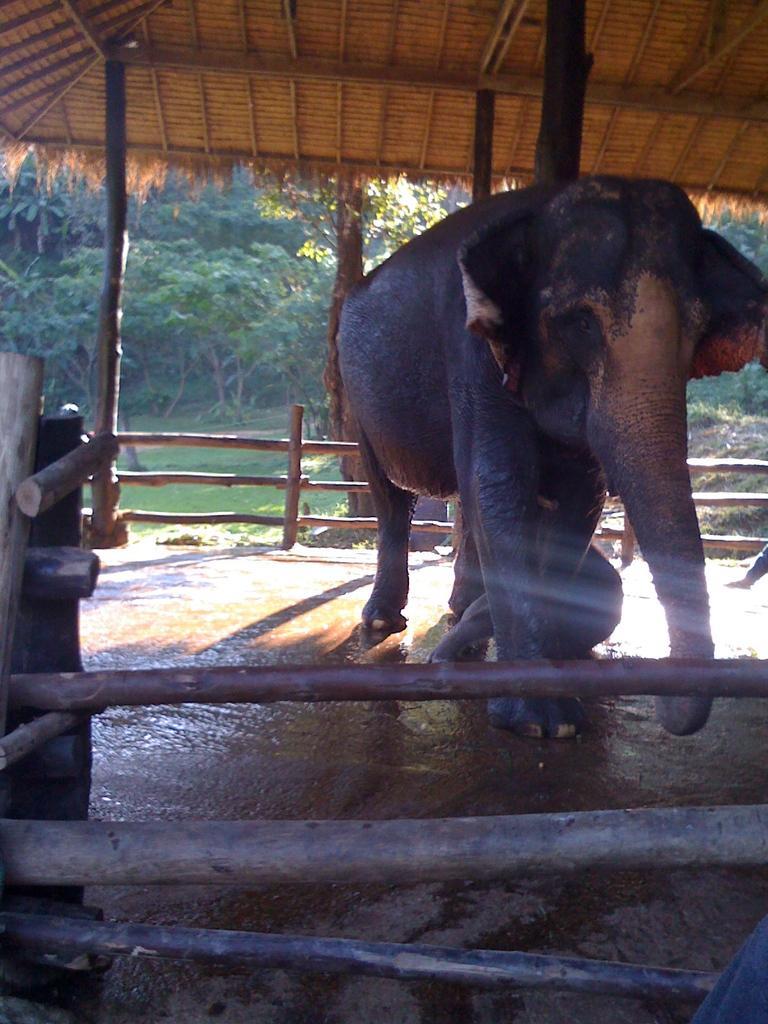In one or two sentences, can you explain what this image depicts? In this image we can see an elephant on the ground. In the background, we can see group of wood poles, a shed, group of trees and the grass. 